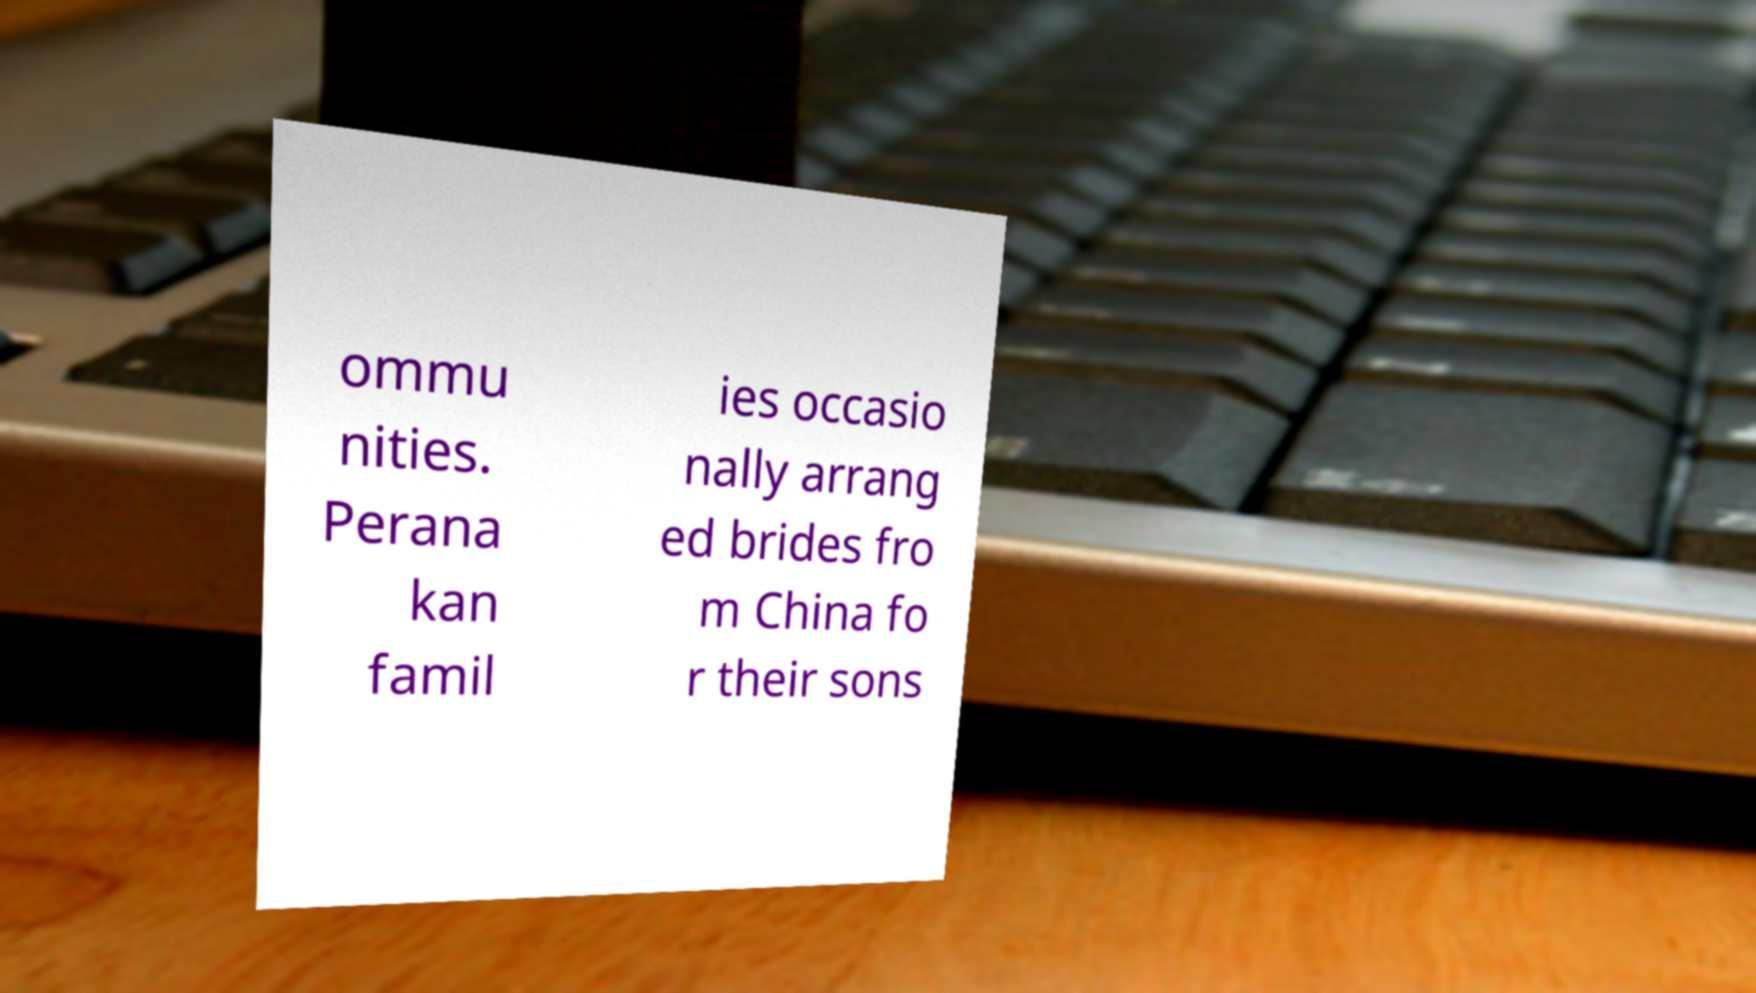For documentation purposes, I need the text within this image transcribed. Could you provide that? ommu nities. Perana kan famil ies occasio nally arrang ed brides fro m China fo r their sons 